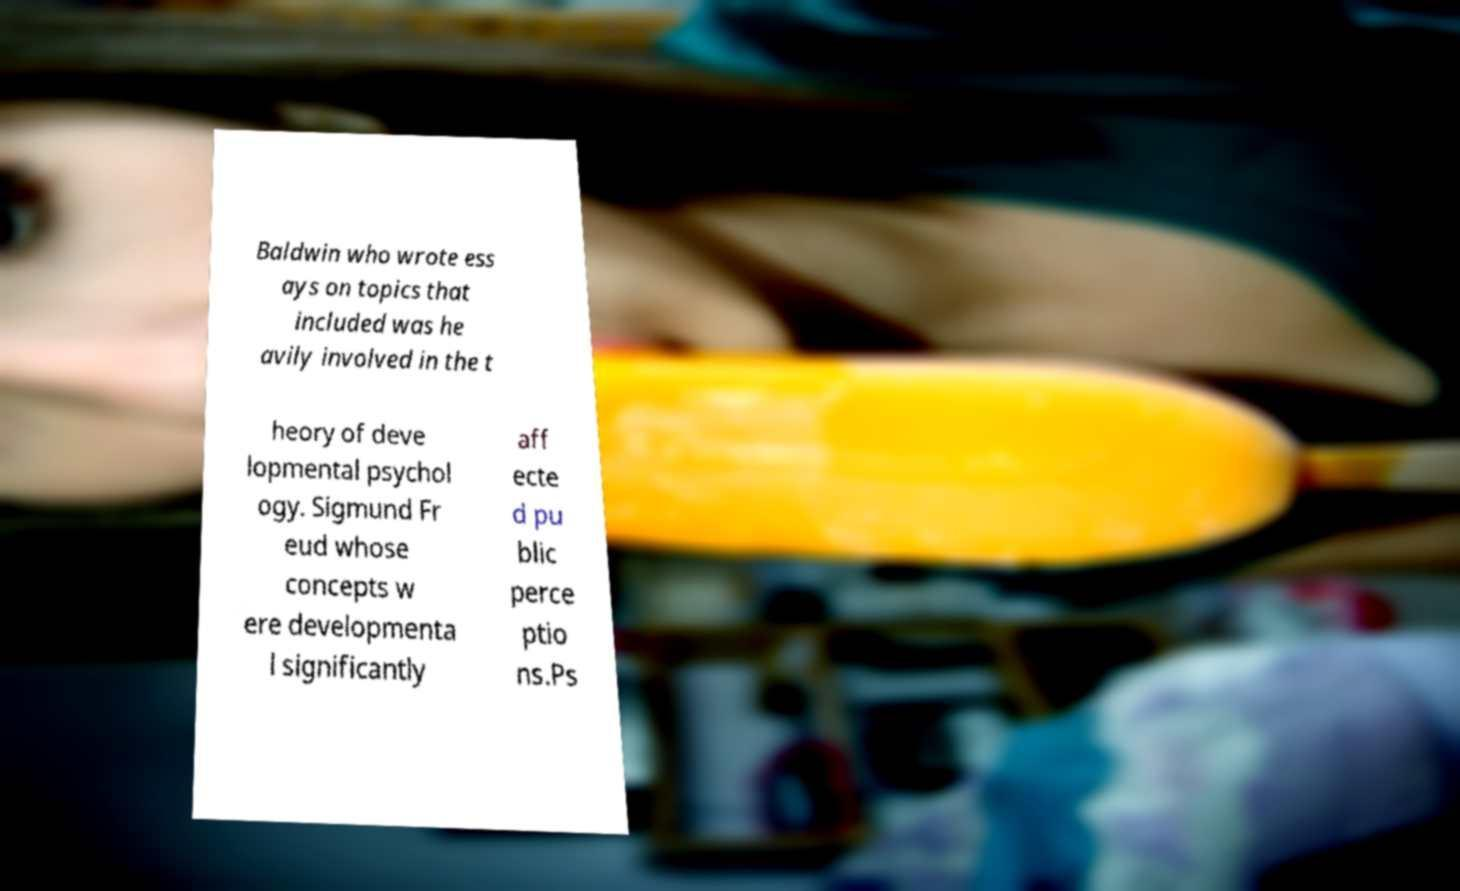Could you extract and type out the text from this image? Baldwin who wrote ess ays on topics that included was he avily involved in the t heory of deve lopmental psychol ogy. Sigmund Fr eud whose concepts w ere developmenta l significantly aff ecte d pu blic perce ptio ns.Ps 